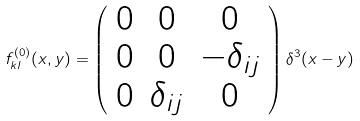Convert formula to latex. <formula><loc_0><loc_0><loc_500><loc_500>f _ { k l } ^ { ( 0 ) } ( x , y ) = \left ( \begin{array} { c c c } 0 & 0 & 0 \\ 0 & 0 & - \delta _ { i j } \\ 0 & \delta _ { i j } & 0 \end{array} \right ) \delta ^ { 3 } ( x - y )</formula> 